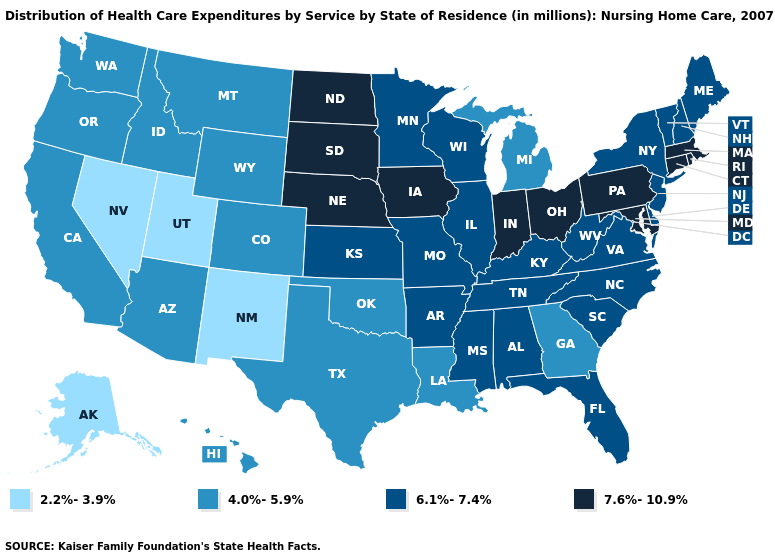Name the states that have a value in the range 7.6%-10.9%?
Give a very brief answer. Connecticut, Indiana, Iowa, Maryland, Massachusetts, Nebraska, North Dakota, Ohio, Pennsylvania, Rhode Island, South Dakota. Among the states that border New Mexico , which have the highest value?
Be succinct. Arizona, Colorado, Oklahoma, Texas. What is the value of Georgia?
Keep it brief. 4.0%-5.9%. Which states have the highest value in the USA?
Answer briefly. Connecticut, Indiana, Iowa, Maryland, Massachusetts, Nebraska, North Dakota, Ohio, Pennsylvania, Rhode Island, South Dakota. Does Illinois have a lower value than Indiana?
Concise answer only. Yes. Among the states that border Massachusetts , which have the highest value?
Short answer required. Connecticut, Rhode Island. What is the value of Wyoming?
Keep it brief. 4.0%-5.9%. What is the highest value in the Northeast ?
Write a very short answer. 7.6%-10.9%. Does Texas have a lower value than Georgia?
Give a very brief answer. No. Name the states that have a value in the range 6.1%-7.4%?
Be succinct. Alabama, Arkansas, Delaware, Florida, Illinois, Kansas, Kentucky, Maine, Minnesota, Mississippi, Missouri, New Hampshire, New Jersey, New York, North Carolina, South Carolina, Tennessee, Vermont, Virginia, West Virginia, Wisconsin. Does the first symbol in the legend represent the smallest category?
Answer briefly. Yes. What is the value of Delaware?
Be succinct. 6.1%-7.4%. What is the value of Tennessee?
Write a very short answer. 6.1%-7.4%. What is the value of Maine?
Be succinct. 6.1%-7.4%. Name the states that have a value in the range 7.6%-10.9%?
Keep it brief. Connecticut, Indiana, Iowa, Maryland, Massachusetts, Nebraska, North Dakota, Ohio, Pennsylvania, Rhode Island, South Dakota. 